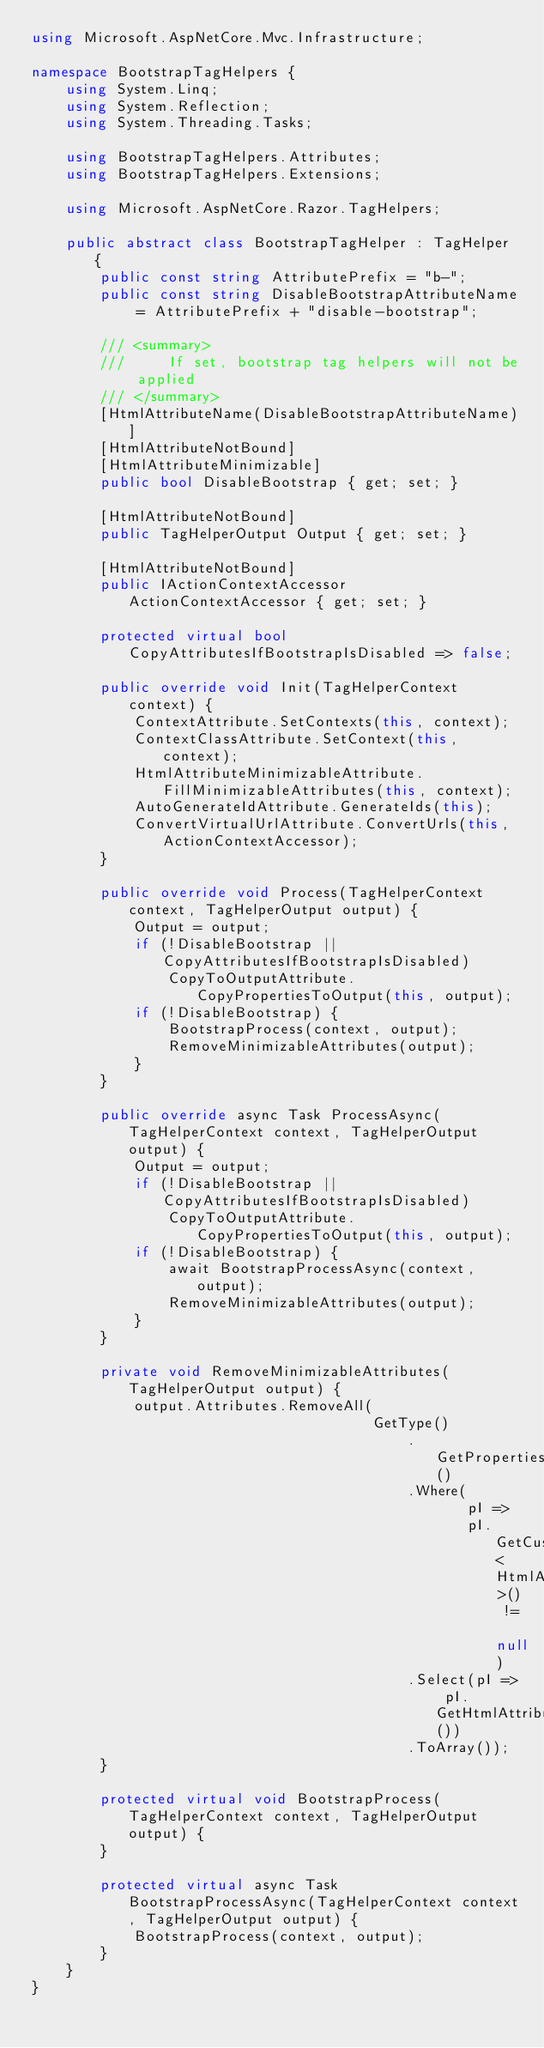<code> <loc_0><loc_0><loc_500><loc_500><_C#_>using Microsoft.AspNetCore.Mvc.Infrastructure;

namespace BootstrapTagHelpers {
    using System.Linq;
    using System.Reflection;
    using System.Threading.Tasks;

    using BootstrapTagHelpers.Attributes;
    using BootstrapTagHelpers.Extensions;

    using Microsoft.AspNetCore.Razor.TagHelpers;

    public abstract class BootstrapTagHelper : TagHelper {
        public const string AttributePrefix = "b-";
        public const string DisableBootstrapAttributeName = AttributePrefix + "disable-bootstrap";

        /// <summary>
        ///     If set, bootstrap tag helpers will not be applied
        /// </summary>
        [HtmlAttributeName(DisableBootstrapAttributeName)]
        [HtmlAttributeNotBound]
        [HtmlAttributeMinimizable]
        public bool DisableBootstrap { get; set; }

        [HtmlAttributeNotBound]
        public TagHelperOutput Output { get; set; }

        [HtmlAttributeNotBound]
        public IActionContextAccessor ActionContextAccessor { get; set; }

        protected virtual bool CopyAttributesIfBootstrapIsDisabled => false;

        public override void Init(TagHelperContext context) {
            ContextAttribute.SetContexts(this, context);
            ContextClassAttribute.SetContext(this, context);
            HtmlAttributeMinimizableAttribute.FillMinimizableAttributes(this, context);
            AutoGenerateIdAttribute.GenerateIds(this);
            ConvertVirtualUrlAttribute.ConvertUrls(this, ActionContextAccessor);
        }

        public override void Process(TagHelperContext context, TagHelperOutput output) {
            Output = output;
            if (!DisableBootstrap || CopyAttributesIfBootstrapIsDisabled)
                CopyToOutputAttribute.CopyPropertiesToOutput(this, output);
            if (!DisableBootstrap) {
                BootstrapProcess(context, output);
                RemoveMinimizableAttributes(output);
            }
        }

        public override async Task ProcessAsync(TagHelperContext context, TagHelperOutput output) {
            Output = output;
            if (!DisableBootstrap || CopyAttributesIfBootstrapIsDisabled)
                CopyToOutputAttribute.CopyPropertiesToOutput(this, output);
            if (!DisableBootstrap) {
                await BootstrapProcessAsync(context, output);
                RemoveMinimizableAttributes(output);
            }
        }

        private void RemoveMinimizableAttributes(TagHelperOutput output) {
            output.Attributes.RemoveAll(
                                        GetType()
                                            .GetProperties()
                                            .Where(
                                                   pI =>
                                                   pI.GetCustomAttribute<HtmlAttributeMinimizableAttribute>() != null)
                                            .Select(pI => pI.GetHtmlAttributeName())
                                            .ToArray());
        }

        protected virtual void BootstrapProcess(TagHelperContext context, TagHelperOutput output) {
        }

        protected virtual async Task BootstrapProcessAsync(TagHelperContext context, TagHelperOutput output) {
            BootstrapProcess(context, output);
        }
    }
}</code> 